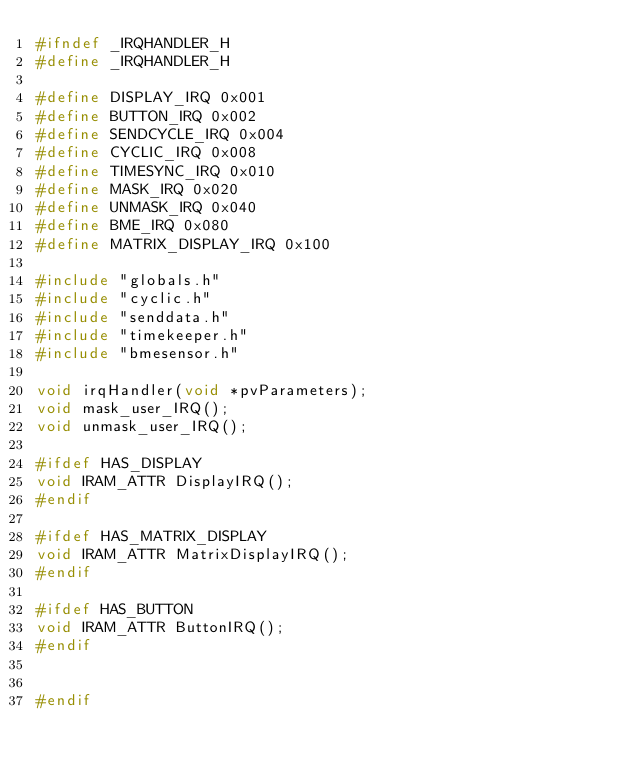Convert code to text. <code><loc_0><loc_0><loc_500><loc_500><_C_>#ifndef _IRQHANDLER_H
#define _IRQHANDLER_H

#define DISPLAY_IRQ 0x001
#define BUTTON_IRQ 0x002
#define SENDCYCLE_IRQ 0x004
#define CYCLIC_IRQ 0x008
#define TIMESYNC_IRQ 0x010
#define MASK_IRQ 0x020
#define UNMASK_IRQ 0x040
#define BME_IRQ 0x080
#define MATRIX_DISPLAY_IRQ 0x100

#include "globals.h"
#include "cyclic.h"
#include "senddata.h"
#include "timekeeper.h"
#include "bmesensor.h"

void irqHandler(void *pvParameters);
void mask_user_IRQ();
void unmask_user_IRQ();

#ifdef HAS_DISPLAY
void IRAM_ATTR DisplayIRQ();
#endif

#ifdef HAS_MATRIX_DISPLAY
void IRAM_ATTR MatrixDisplayIRQ();
#endif

#ifdef HAS_BUTTON
void IRAM_ATTR ButtonIRQ();
#endif


#endif</code> 